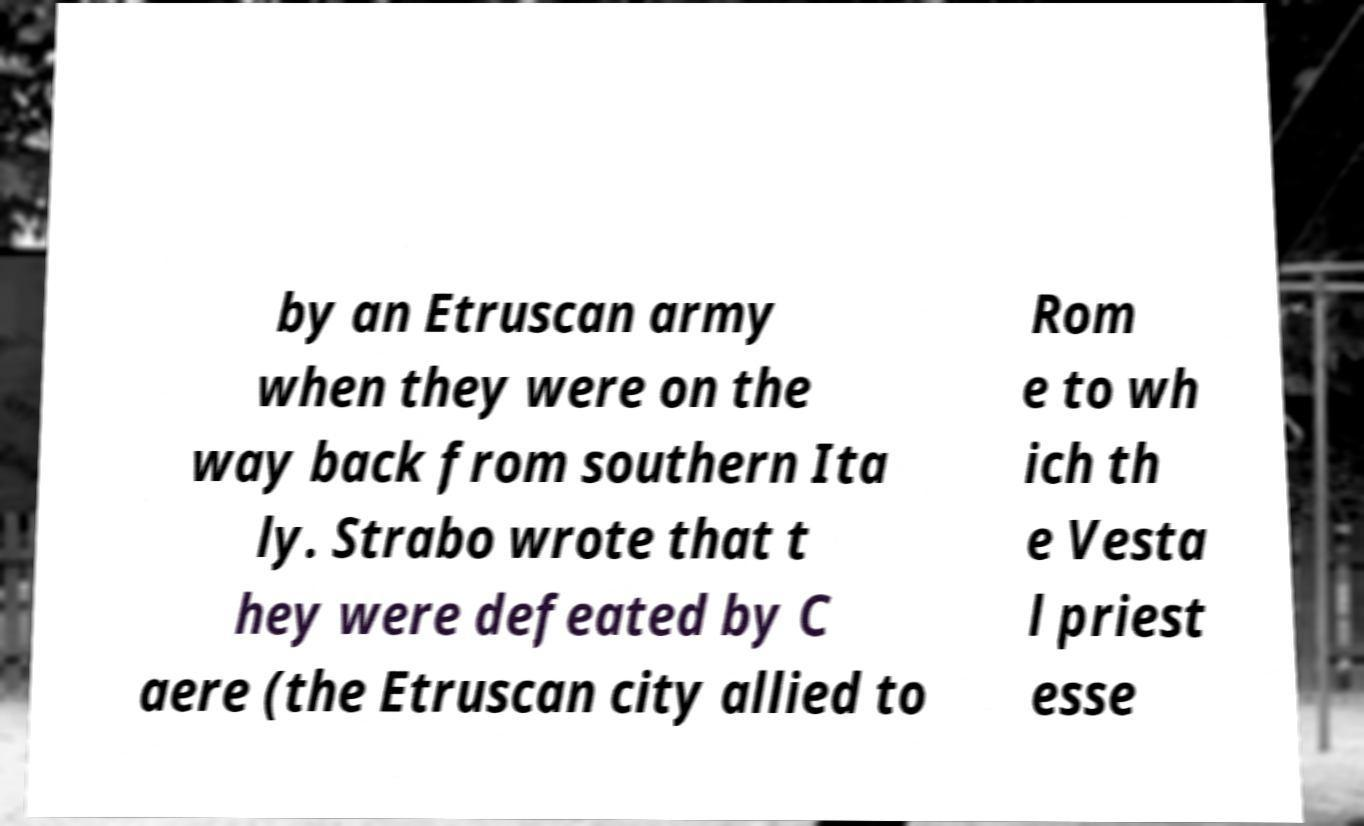For documentation purposes, I need the text within this image transcribed. Could you provide that? by an Etruscan army when they were on the way back from southern Ita ly. Strabo wrote that t hey were defeated by C aere (the Etruscan city allied to Rom e to wh ich th e Vesta l priest esse 